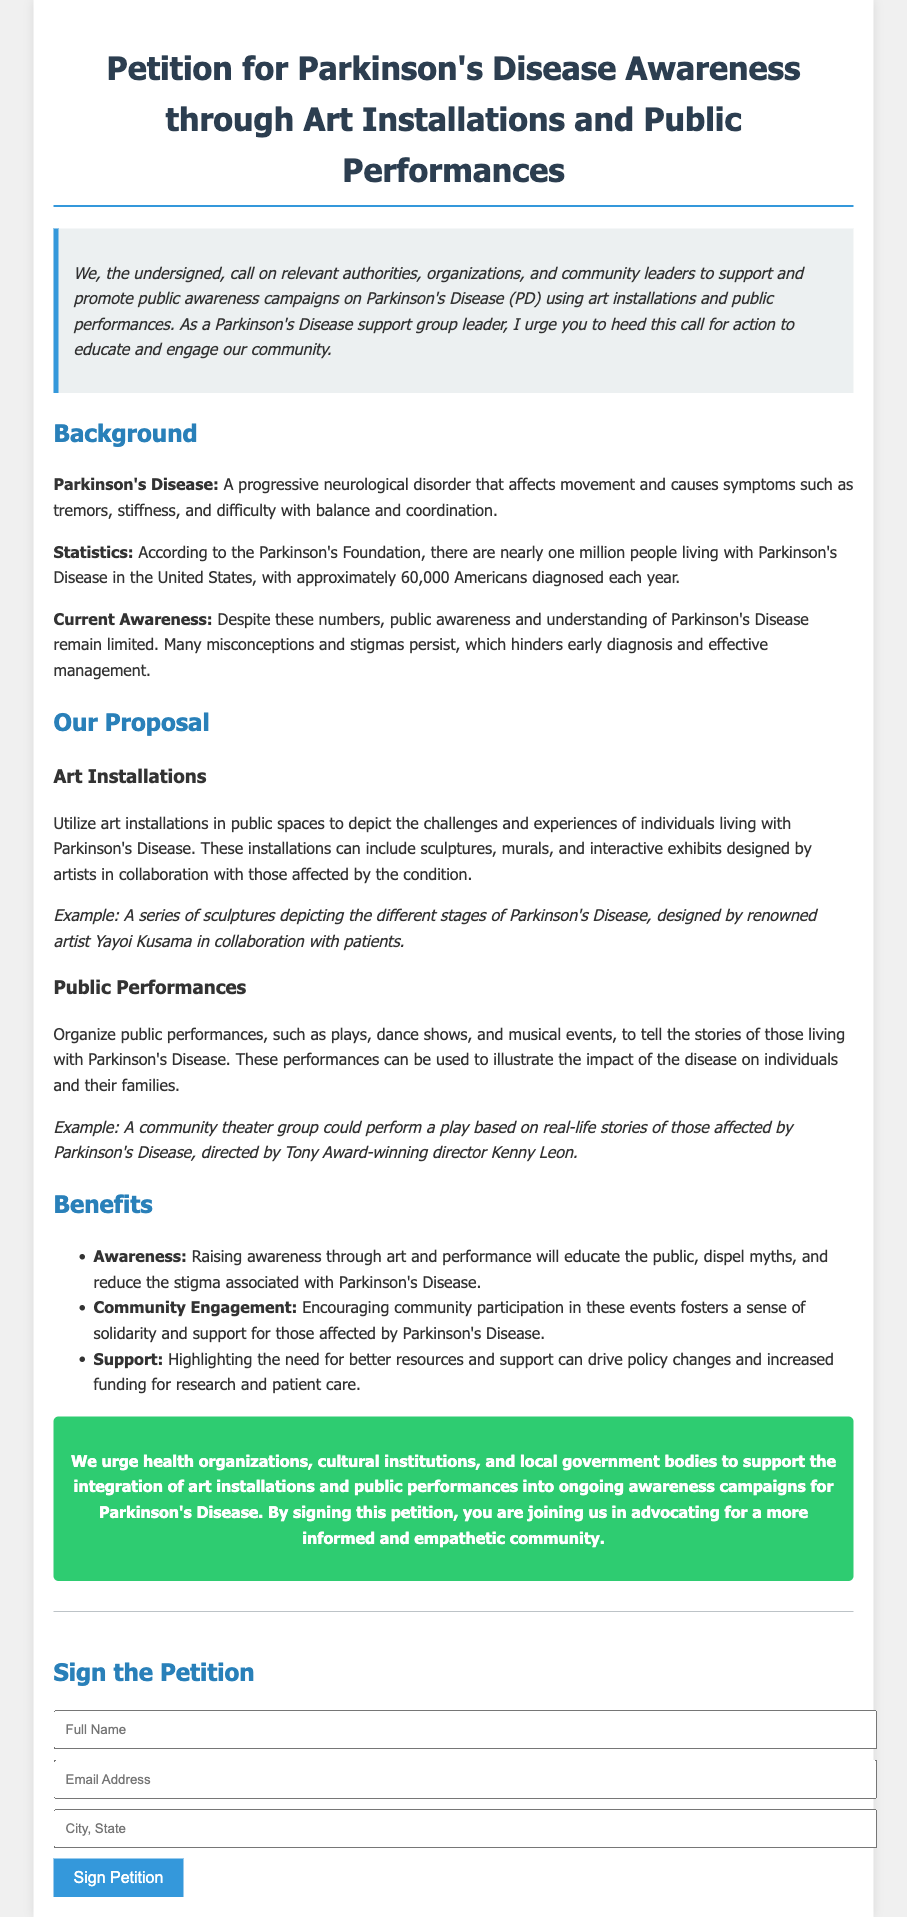what is the title of the petition? The title is explicitly stated at the top of the document and reflects the main topic of the petition.
Answer: Petition for Parkinson's Disease Awareness through Art Installations and Public Performances how many people are living with Parkinson's Disease in the United States? The document includes a statistic that quantifies the current number of individuals with Parkinson's Disease.
Answer: nearly one million who can support the petition according to the call-to-action? The document specifies several groups that are encouraged to assist with the initiative.
Answer: health organizations, cultural institutions, local government bodies what type of art is proposed to raise awareness for Parkinson's Disease? The document lists specific art forms that will be utilized to promote understanding of Parkinson's Disease.
Answer: art installations, public performances what is one benefit of raising awareness through art and performance? The document outlines several advantages of this proposal and provides a specific focus on one of them.
Answer: educate the public who is an example of an artist mentioned in the petition? The document provides specific references to notable artists that could be involved in the proposed initiatives.
Answer: Yayoi Kusama 